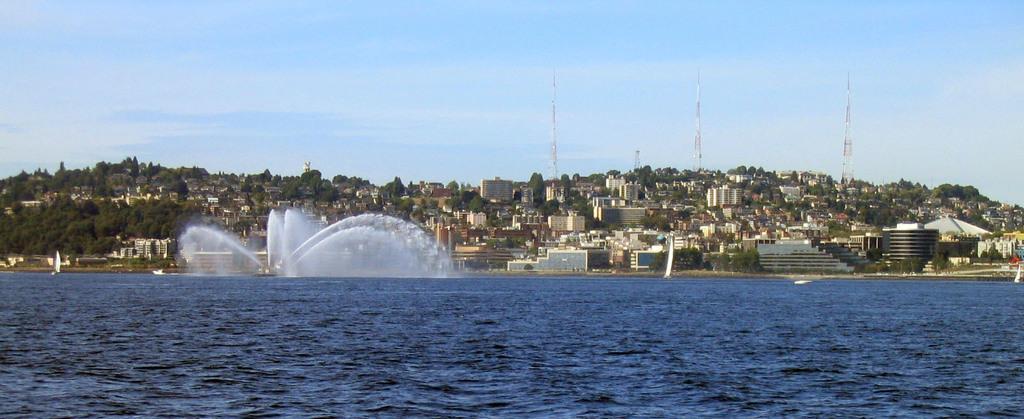Please provide a concise description of this image. In the picture we can see a water which is blue in color and far away from it, we can see the fountain and behind it, we can see trees, houses, buildings, tower buildings and in the background we can see a sky with clouds. 